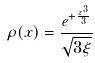<formula> <loc_0><loc_0><loc_500><loc_500>\rho ( x ) = \frac { e ^ { + \frac { x ^ { 3 } } { 3 } } } { \sqrt { 3 \xi } }</formula> 